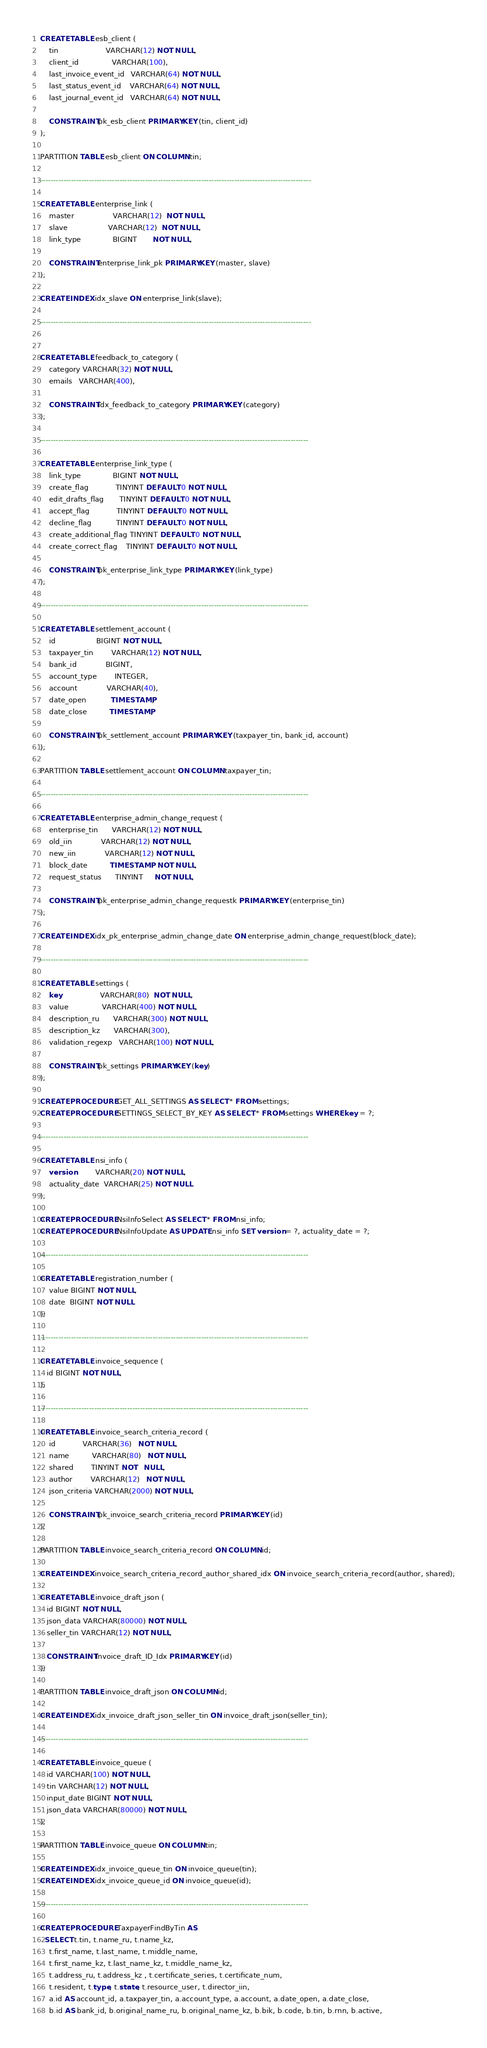<code> <loc_0><loc_0><loc_500><loc_500><_SQL_>
CREATE TABLE esb_client (
    tin                     VARCHAR(12) NOT NULL,
    client_id               VARCHAR(100),
    last_invoice_event_id   VARCHAR(64) NOT NULL,
    last_status_event_id    VARCHAR(64) NOT NULL,
    last_journal_event_id   VARCHAR(64) NOT NULL,

    CONSTRAINT pk_esb_client PRIMARY KEY (tin, client_id)
);

PARTITION TABLE esb_client ON COLUMN tin;

----------------------------------------------------------------------------------------------------------

CREATE TABLE enterprise_link (
    master                 VARCHAR(12)  NOT NULL,
    slave                  VARCHAR(12)  NOT NULL,
    link_type              BIGINT       NOT NULL,

    CONSTRAINT enterprise_link_pk PRIMARY KEY (master, slave)
);

CREATE INDEX idx_slave ON enterprise_link(slave);

----------------------------------------------------------------------------------------------------------


CREATE TABLE feedback_to_category (
    category VARCHAR(32) NOT NULL,
    emails   VARCHAR(400),

    CONSTRAINT idx_feedback_to_category PRIMARY KEY (category)
);

---------------------------------------------------------------------------------------------------------

CREATE TABLE enterprise_link_type (
    link_type              BIGINT NOT NULL,
    create_flag            TINYINT DEFAULT 0 NOT NULL,
    edit_drafts_flag       TINYINT DEFAULT 0 NOT NULL,
    accept_flag            TINYINT DEFAULT 0 NOT NULL,
    decline_flag           TINYINT DEFAULT 0 NOT NULL,
    create_additional_flag TINYINT DEFAULT 0 NOT NULL,
    create_correct_flag    TINYINT DEFAULT 0 NOT NULL,

    CONSTRAINT pk_enterprise_link_type PRIMARY KEY (link_type)
);

---------------------------------------------------------------------------------------------------------

CREATE TABLE settlement_account (
    id                  BIGINT NOT NULL,
    taxpayer_tin        VARCHAR(12) NOT NULL,
    bank_id             BIGINT,
    account_type        INTEGER,
    account             VARCHAR(40), 
    date_open           TIMESTAMP,
    date_close          TIMESTAMP,

    CONSTRAINT pk_settlement_account PRIMARY KEY (taxpayer_tin, bank_id, account)
);

PARTITION TABLE settlement_account ON COLUMN taxpayer_tin;

---------------------------------------------------------------------------------------------------------

CREATE TABLE enterprise_admin_change_request (
    enterprise_tin      VARCHAR(12) NOT NULL,
    old_iin             VARCHAR(12) NOT NULL,
    new_iin             VARCHAR(12) NOT NULL,
    block_date          TIMESTAMP   NOT NULL,
    request_status      TINYINT     NOT NULL,

    CONSTRAINT pk_enterprise_admin_change_requestk PRIMARY KEY (enterprise_tin)
);

CREATE INDEX idx_pk_enterprise_admin_change_date ON enterprise_admin_change_request(block_date);

---------------------------------------------------------------------------------------------------------

CREATE TABLE settings (
    key                 VARCHAR(80)  NOT NULL,
    value               VARCHAR(400) NOT NULL,
    description_ru      VARCHAR(300) NOT NULL,
    description_kz      VARCHAR(300),
    validation_regexp   VARCHAR(100) NOT NULL,

    CONSTRAINT pk_settings PRIMARY KEY (key)
);

CREATE PROCEDURE GET_ALL_SETTINGS AS SELECT * FROM settings;
CREATE PROCEDURE SETTINGS_SELECT_BY_KEY AS SELECT * FROM settings WHERE key = ?;

---------------------------------------------------------------------------------------------------------

CREATE TABLE nsi_info (
    version         VARCHAR(20) NOT NULL,
    actuality_date  VARCHAR(25) NOT NULL
);

CREATE PROCEDURE NsiInfoSelect AS SELECT * FROM nsi_info;
CREATE PROCEDURE NsiInfoUpdate AS UPDATE nsi_info SET version = ?, actuality_date = ?;

---------------------------------------------------------------------------------------------------------

CREATE TABLE registration_number (
    value BIGINT NOT NULL,
    date  BIGINT NOT NULL
);

---------------------------------------------------------------------------------------------------------

CREATE TABLE invoice_sequence (
   id BIGINT NOT NULL,
);

---------------------------------------------------------------------------------------------------------

CREATE TABLE invoice_search_criteria_record (
    id            VARCHAR(36)   NOT NULL,
    name          VARCHAR(80)   NOT NULL,
    shared        TINYINT NOT   NULL,
    author        VARCHAR(12)   NOT NULL,
    json_criteria VARCHAR(2000) NOT NULL,

    CONSTRAINT pk_invoice_search_criteria_record PRIMARY KEY (id)
);

PARTITION TABLE invoice_search_criteria_record ON COLUMN id;

CREATE INDEX invoice_search_criteria_record_author_shared_idx ON invoice_search_criteria_record(author, shared);

CREATE TABLE invoice_draft_json (
   id BIGINT NOT NULL,
   json_data VARCHAR(80000) NOT NULL,
   seller_tin VARCHAR(12) NOT NULL,

   CONSTRAINT Invoice_draft_ID_Idx PRIMARY KEY (id)
);

PARTITION TABLE invoice_draft_json ON COLUMN id;

CREATE INDEX idx_invoice_draft_json_seller_tin ON invoice_draft_json(seller_tin);

---------------------------------------------------------------------------------------------------------

CREATE TABLE invoice_queue (
   id VARCHAR(100) NOT NULL,
   tin VARCHAR(12) NOT NULL,
   input_date BIGINT NOT NULL,
   json_data VARCHAR(80000) NOT NULL,
);

PARTITION TABLE invoice_queue ON COLUMN tin;

CREATE INDEX idx_invoice_queue_tin ON invoice_queue(tin);
CREATE INDEX idx_invoice_queue_id ON invoice_queue(id);

---------------------------------------------------------------------------------------------------------

CREATE PROCEDURE TaxpayerFindByTin AS
  SELECT t.tin, t.name_ru, t.name_kz,
    t.first_name, t.last_name, t.middle_name,
    t.first_name_kz, t.last_name_kz, t.middle_name_kz,
    t.address_ru, t.address_kz , t.certificate_series, t.certificate_num,
    t.resident, t.type, t.state, t.resource_user, t.director_iin,
    a.id AS account_id, a.taxpayer_tin, a.account_type, a.account, a.date_open, a.date_close,
    b.id AS bank_id, b.original_name_ru, b.original_name_kz, b.bik, b.code, b.tin, b.rnn, b.active,</code> 